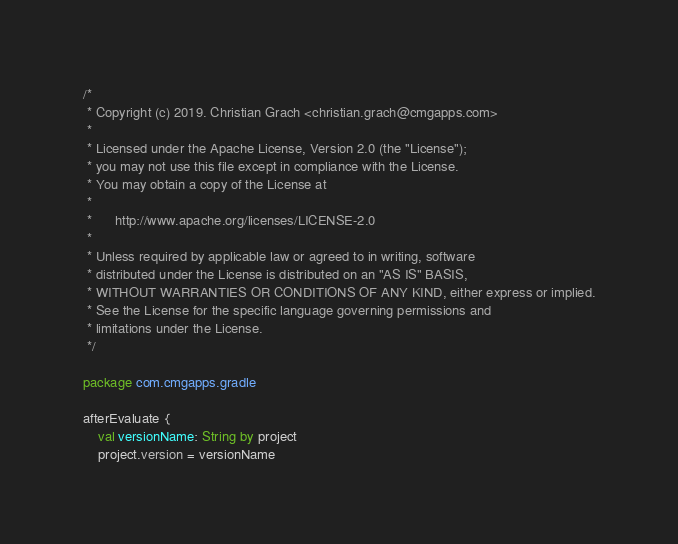Convert code to text. <code><loc_0><loc_0><loc_500><loc_500><_Kotlin_>/*
 * Copyright (c) 2019. Christian Grach <christian.grach@cmgapps.com>
 *
 * Licensed under the Apache License, Version 2.0 (the "License");
 * you may not use this file except in compliance with the License.
 * You may obtain a copy of the License at
 *
 *      http://www.apache.org/licenses/LICENSE-2.0
 *
 * Unless required by applicable law or agreed to in writing, software
 * distributed under the License is distributed on an "AS IS" BASIS,
 * WITHOUT WARRANTIES OR CONDITIONS OF ANY KIND, either express or implied.
 * See the License for the specific language governing permissions and
 * limitations under the License.
 */

package com.cmgapps.gradle

afterEvaluate {
    val versionName: String by project
    project.version = versionName
</code> 